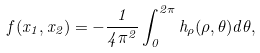<formula> <loc_0><loc_0><loc_500><loc_500>f ( x _ { 1 } , x _ { 2 } ) = - \frac { 1 } { 4 \pi ^ { 2 } } \int _ { 0 } ^ { 2 \pi } h _ { \rho } ( \rho , \theta ) d \theta ,</formula> 